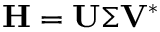<formula> <loc_0><loc_0><loc_500><loc_500>H = U \Sigma V ^ { * }</formula> 